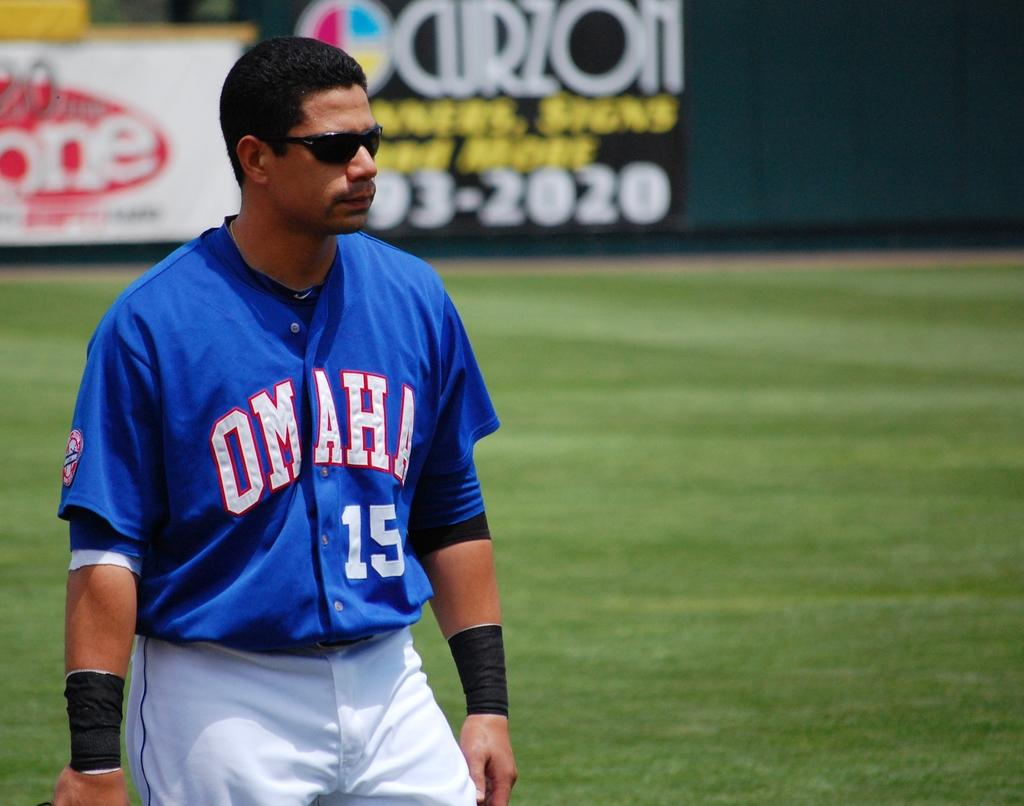Provide a one-sentence caption for the provided image. A player for Omaha, number 15, is wearing sunglasses and has black wrist bands. 